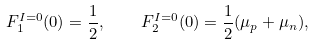<formula> <loc_0><loc_0><loc_500><loc_500>F ^ { I = 0 } _ { 1 } ( 0 ) = \frac { 1 } { 2 } , \quad F ^ { I = 0 } _ { 2 } ( 0 ) = \frac { 1 } { 2 } ( \mu _ { p } + \mu _ { n } ) ,</formula> 